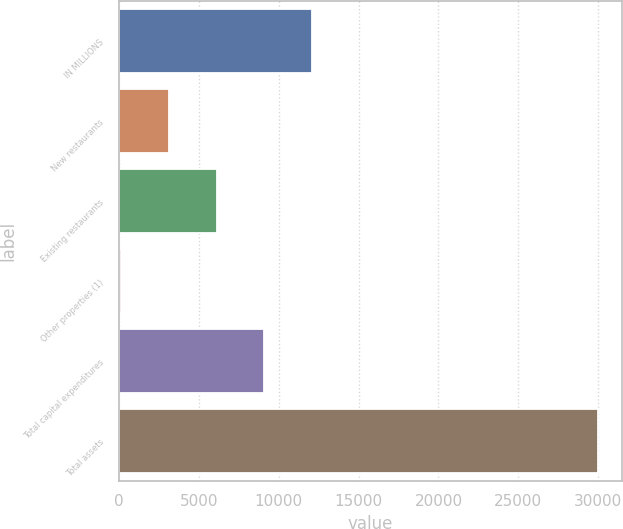Convert chart. <chart><loc_0><loc_0><loc_500><loc_500><bar_chart><fcel>IN MILLIONS<fcel>New restaurants<fcel>Existing restaurants<fcel>Other properties (1)<fcel>Total capital expenditures<fcel>Total assets<nl><fcel>12083.2<fcel>3130.3<fcel>6114.6<fcel>146<fcel>9098.9<fcel>29989<nl></chart> 